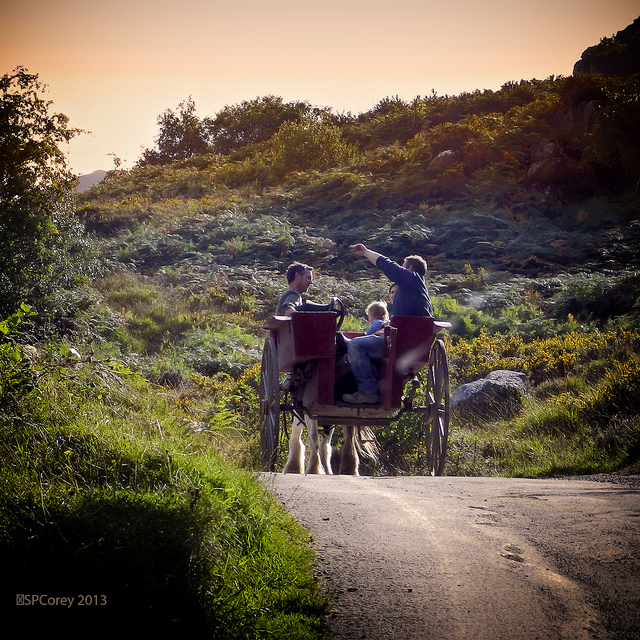Please transcribe the text information in this image. SPCorey 2013 